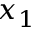<formula> <loc_0><loc_0><loc_500><loc_500>x _ { 1 }</formula> 